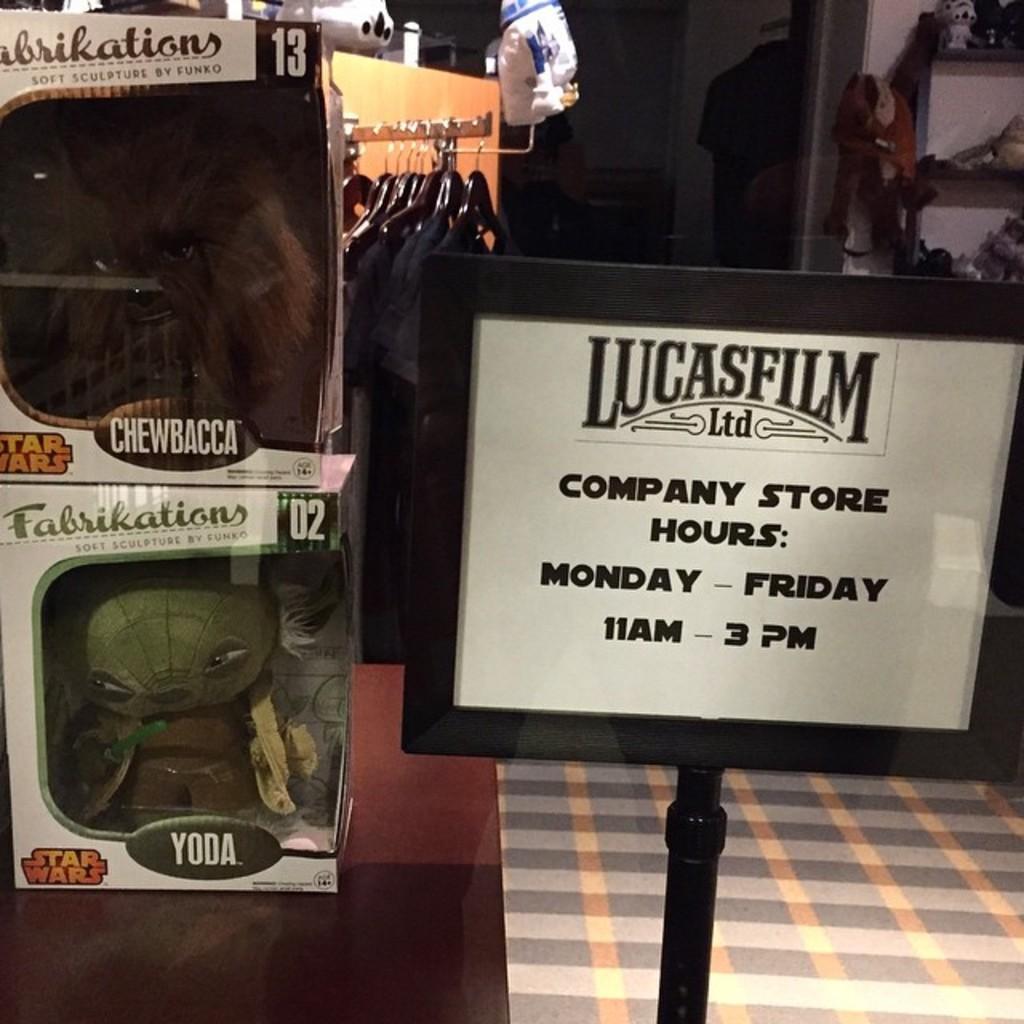In one or two sentences, can you explain what this image depicts? In this picture I can see couple of toys in the boxes on the table and I can see few clothes to the hangers and I can see a board with some text and a soft toy hanging to the rack and I can see few articles in the rack. 